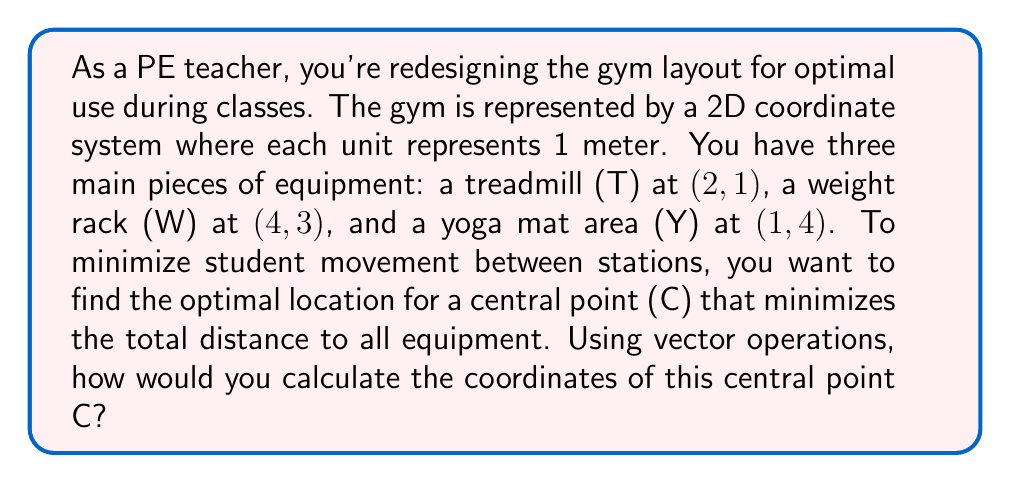Provide a solution to this math problem. Let's approach this step-by-step using vector operations:

1) First, let's represent each equipment location as a vector:
   $$\vec{T} = \begin{pmatrix} 2 \\ 1 \end{pmatrix}, \vec{W} = \begin{pmatrix} 4 \\ 3 \end{pmatrix}, \vec{Y} = \begin{pmatrix} 1 \\ 4 \end{pmatrix}$$

2) The optimal central point C will be the average position of all equipment. We can calculate this using vector addition and scalar multiplication:

   $$\vec{C} = \frac{1}{3}(\vec{T} + \vec{W} + \vec{Y})$$

3) Let's perform the vector addition inside the parentheses:
   $$\vec{T} + \vec{W} + \vec{Y} = \begin{pmatrix} 2 \\ 1 \end{pmatrix} + \begin{pmatrix} 4 \\ 3 \end{pmatrix} + \begin{pmatrix} 1 \\ 4 \end{pmatrix} = \begin{pmatrix} 7 \\ 8 \end{pmatrix}$$

4) Now, we multiply this result by $\frac{1}{3}$:
   $$\vec{C} = \frac{1}{3}\begin{pmatrix} 7 \\ 8 \end{pmatrix} = \begin{pmatrix} 7/3 \\ 8/3 \end{pmatrix}$$

5) Therefore, the coordinates of the central point C are $(7/3, 8/3)$ or approximately $(2.33, 2.67)$.

This point C minimizes the total distance to all equipment, making it the most efficient location for students to move between stations during PE classes.
Answer: $(7/3, 8/3)$ 